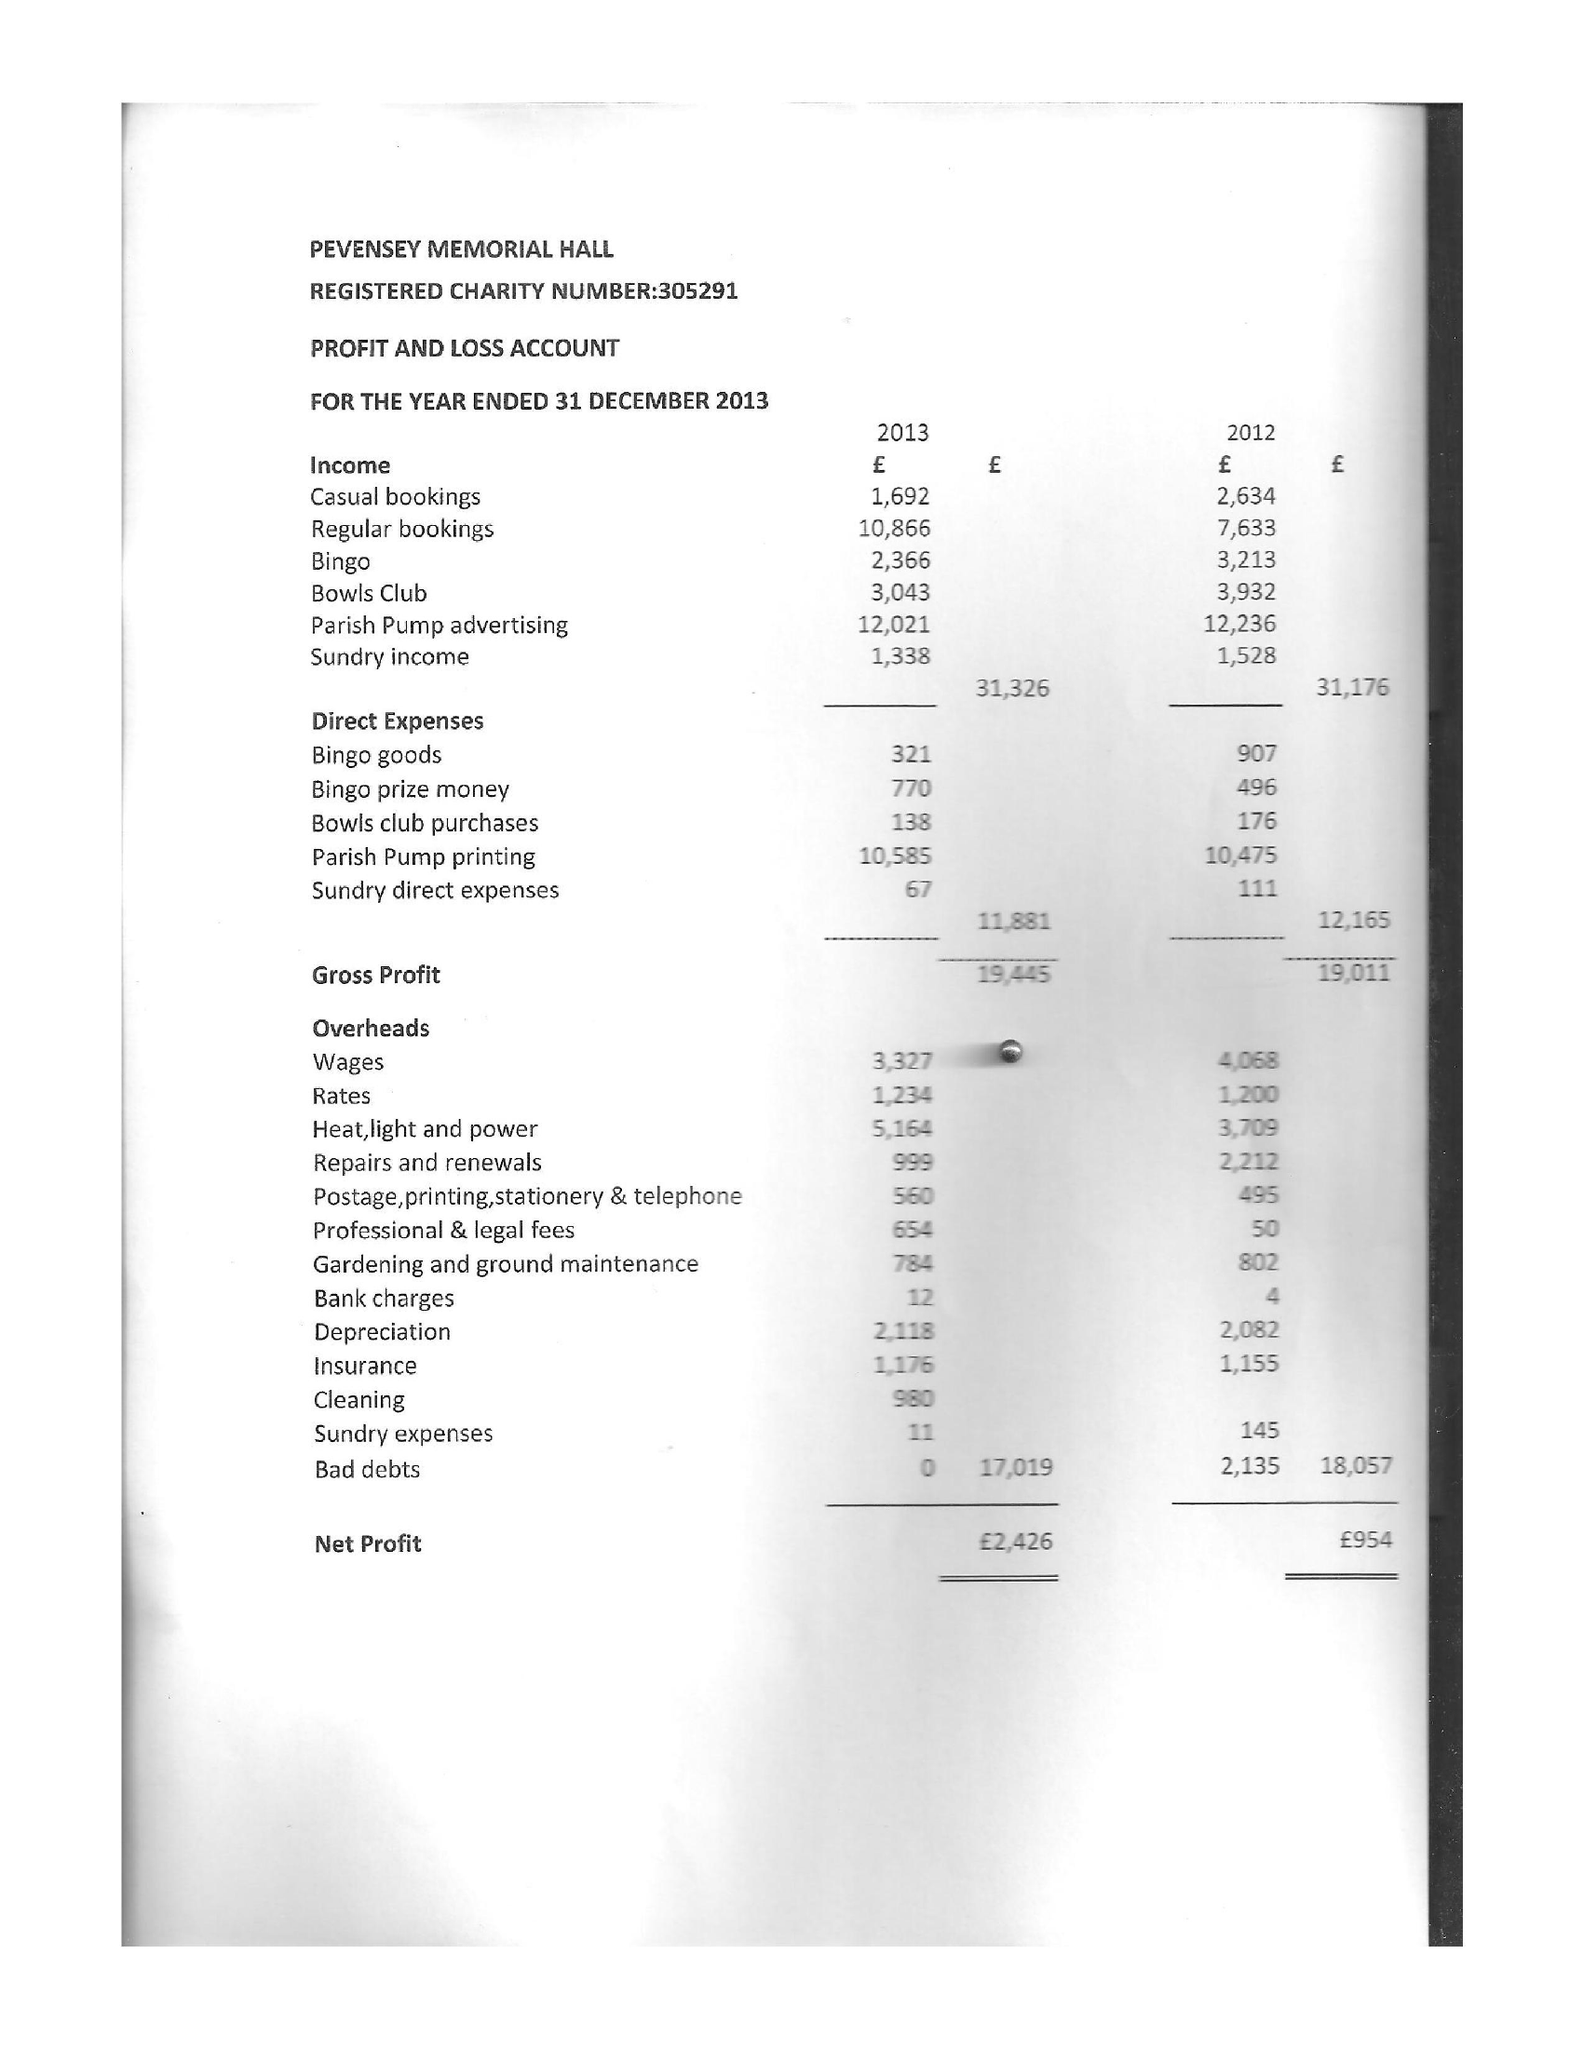What is the value for the charity_number?
Answer the question using a single word or phrase. 305291 